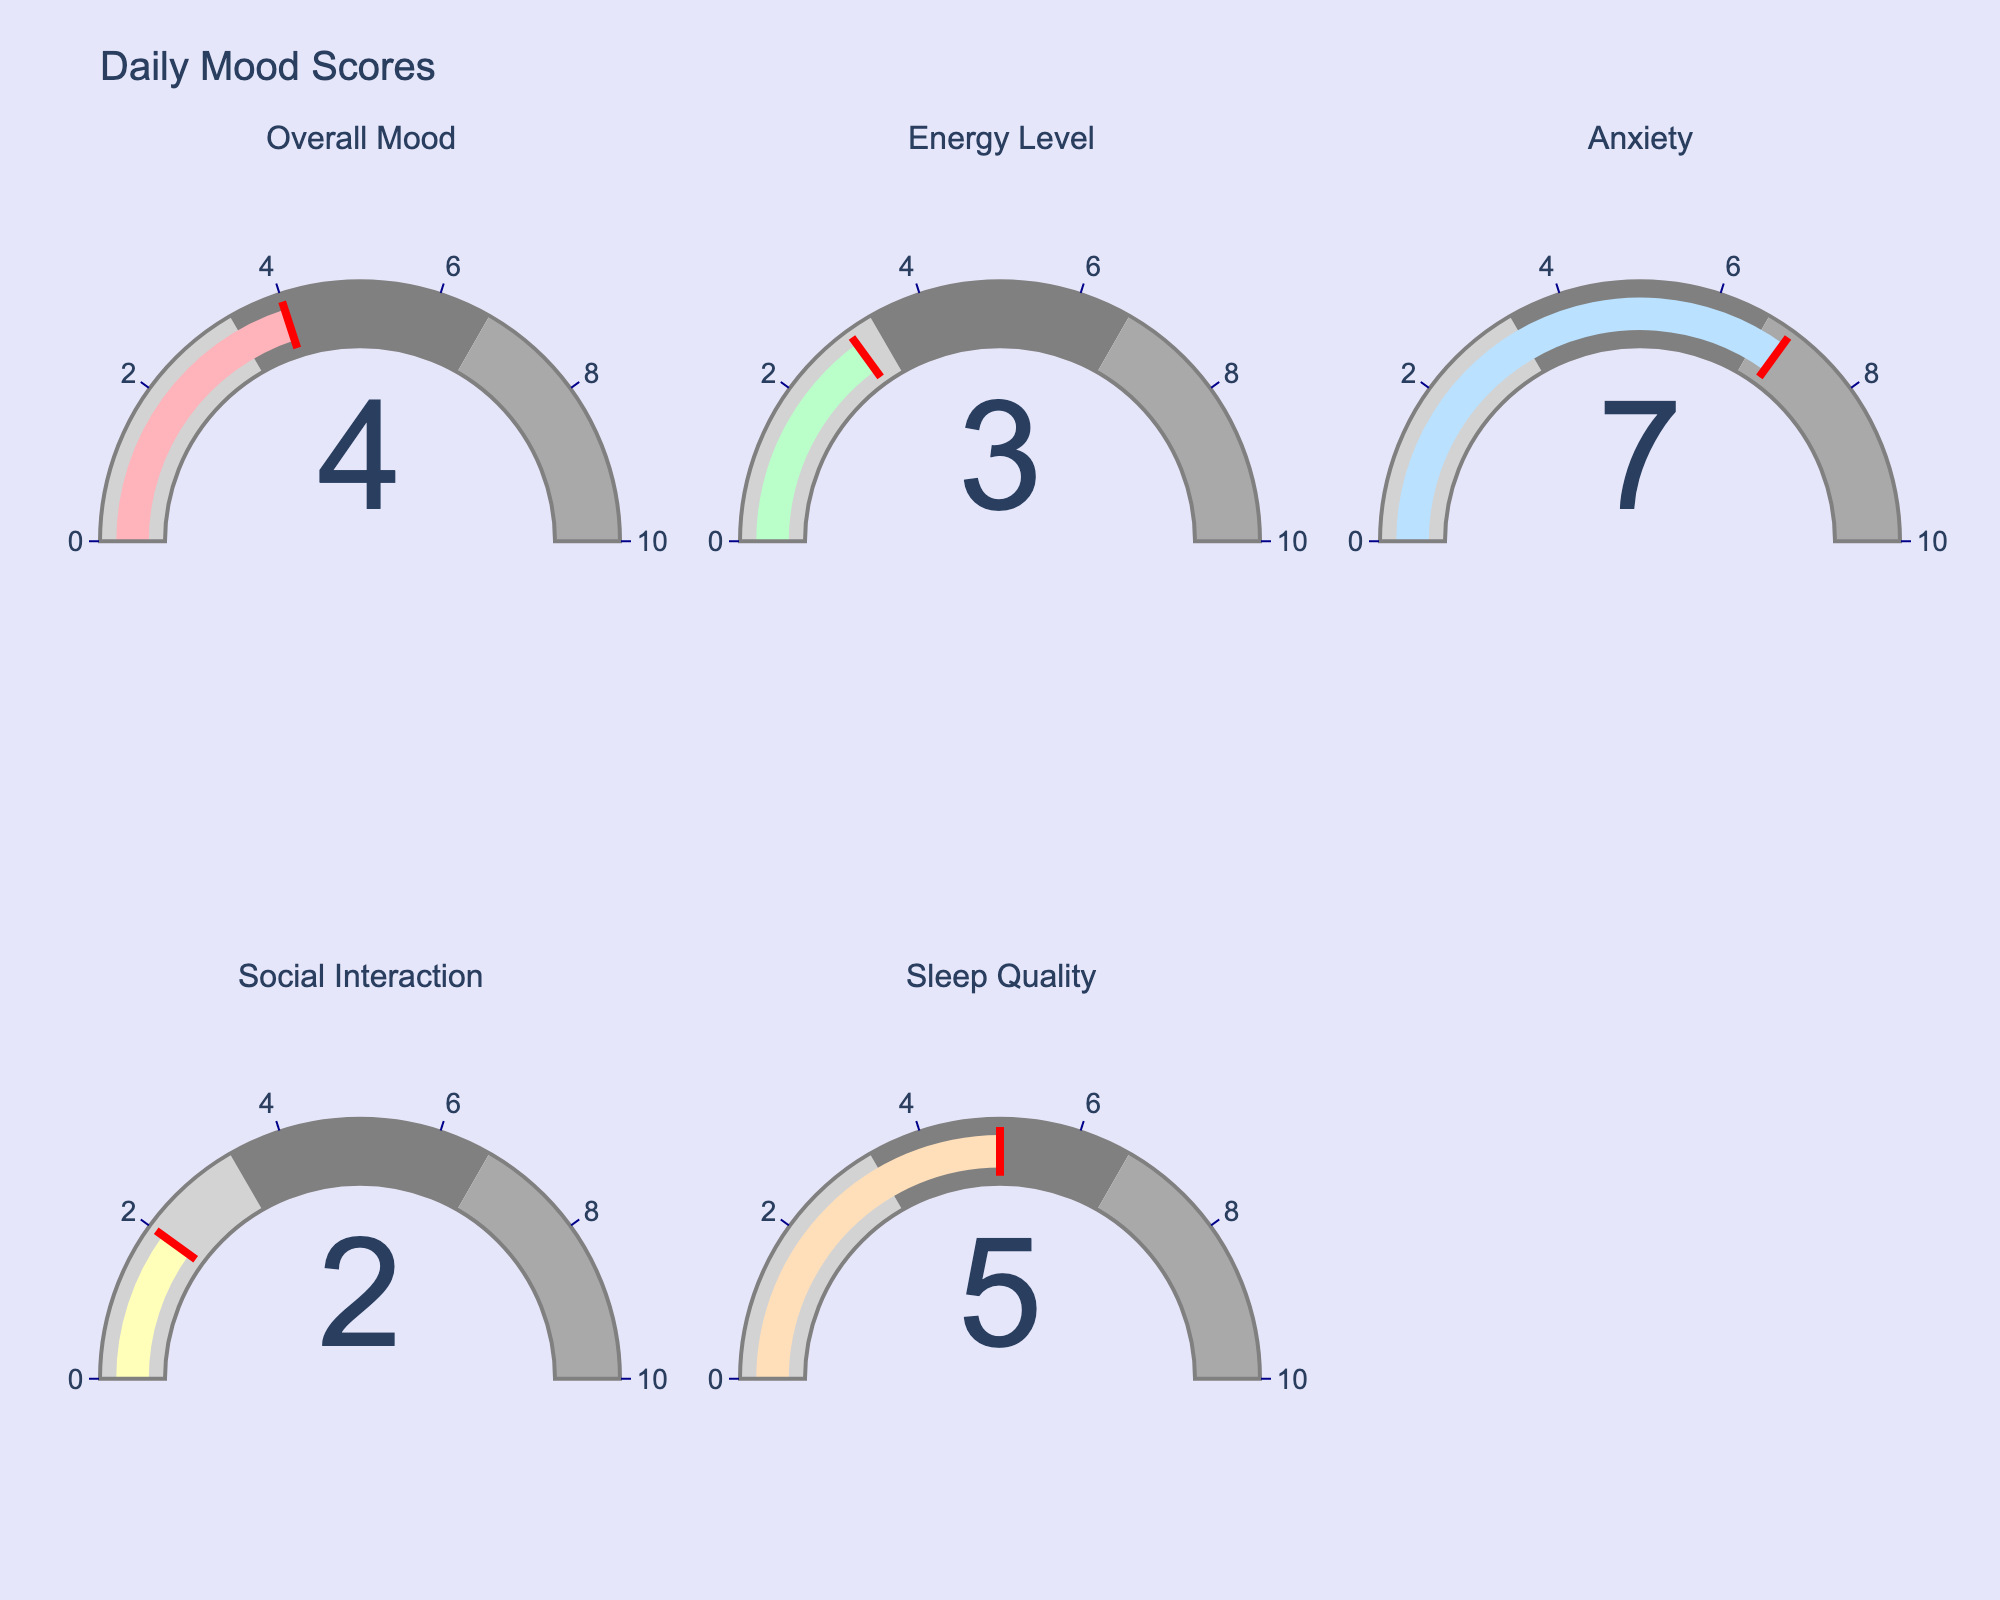What's the title of the plot? The title is located at the top of the figure, usually in larger font size for emphasis.
Answer: Daily Mood Scores Which mood has the highest score? By inspecting the numbers displayed on each gauge chart, Anxiety has the highest score of 7.
Answer: Anxiety Calculate the average score of all mood indicators. Add all the scores: 4 (Overall Mood) + 3 (Energy Level) + 7 (Anxiety) + 2 (Social Interaction) + 5 (Sleep Quality) = 21. Then divide by the number of indicators, which is 5. 21/5 = 4.2.
Answer: 4.2 Compare the scores of Social Interaction and Sleep Quality. Which one is higher? Social Interaction has a score of 2, while Sleep Quality has a score of 5. Therefore, Sleep Quality is higher.
Answer: Sleep Quality Which indicators fall into the highest score range (6.66 to 10)? The gauge chart uses different colors to denote different ranges. By cross-referencing the scores with the ranges, only Anxiety falls in the range of 6.66 to 10 with a score of 7.
Answer: Anxiety 